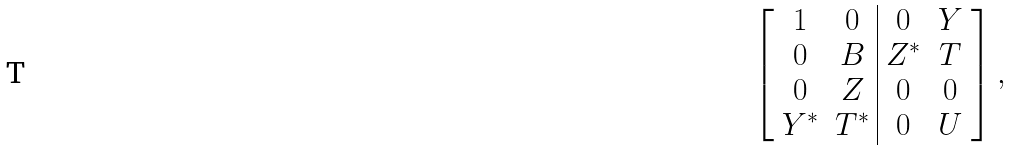<formula> <loc_0><loc_0><loc_500><loc_500>\left [ \begin{array} { c c | c c } 1 & 0 & 0 & Y \\ 0 & B & Z ^ { * } & T \\ 0 & Z & 0 & 0 \\ Y ^ { * } & T ^ { * } & 0 & U \end{array} \right ] ,</formula> 